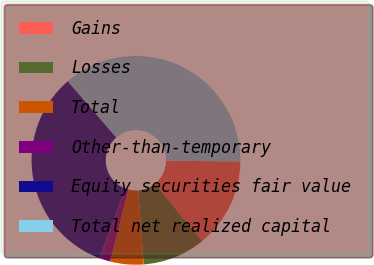Convert chart. <chart><loc_0><loc_0><loc_500><loc_500><pie_chart><fcel>Gains<fcel>Losses<fcel>Total<fcel>Other-than-temporary<fcel>Equity securities fair value<fcel>Total net realized capital<nl><fcel>13.92%<fcel>9.72%<fcel>5.16%<fcel>1.69%<fcel>33.02%<fcel>36.49%<nl></chart> 